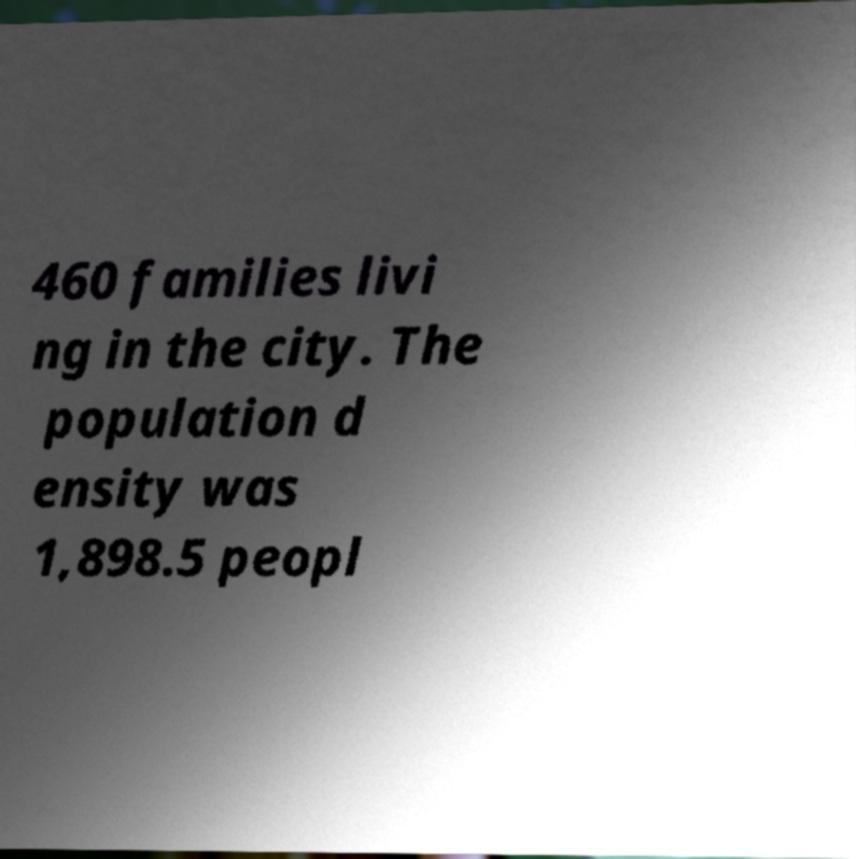Could you assist in decoding the text presented in this image and type it out clearly? 460 families livi ng in the city. The population d ensity was 1,898.5 peopl 